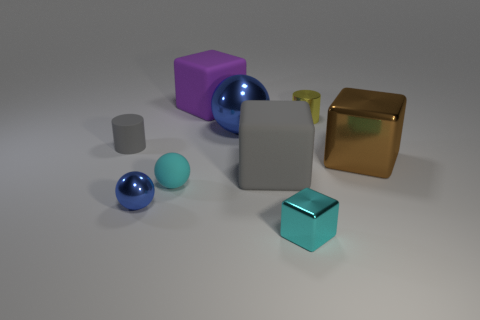What number of other objects are there of the same shape as the tiny yellow metallic object?
Offer a terse response. 1. What number of big blue objects have the same shape as the brown metal thing?
Give a very brief answer. 0. Does the large matte object behind the large gray block have the same color as the large metallic cube?
Provide a short and direct response. No. There is a object behind the yellow object that is to the right of the big rubber block on the right side of the large blue metallic object; what is its shape?
Your answer should be compact. Cube. There is a matte sphere; is its size the same as the cube in front of the large gray thing?
Offer a very short reply. Yes. Are there any cyan matte things that have the same size as the brown metal thing?
Offer a very short reply. No. What number of other objects are the same material as the large sphere?
Your response must be concise. 4. There is a small object that is both behind the cyan matte ball and right of the gray block; what is its color?
Ensure brevity in your answer.  Yellow. Does the blue object that is behind the small blue shiny ball have the same material as the gray object that is right of the big purple rubber object?
Your answer should be compact. No. Does the cyan thing to the right of the cyan matte object have the same size as the gray rubber cube?
Ensure brevity in your answer.  No. 